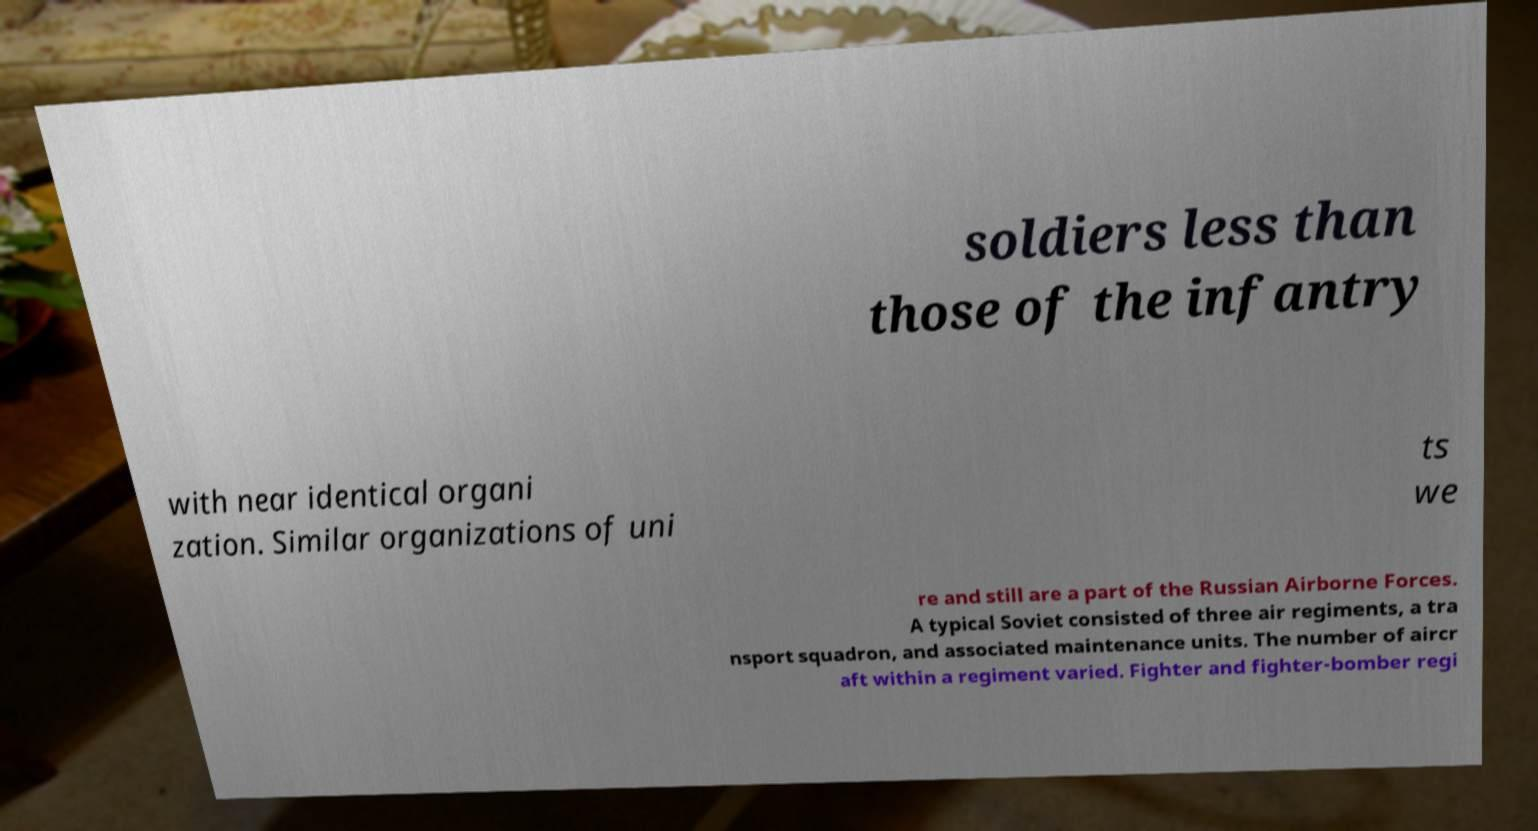Could you assist in decoding the text presented in this image and type it out clearly? soldiers less than those of the infantry with near identical organi zation. Similar organizations of uni ts we re and still are a part of the Russian Airborne Forces. A typical Soviet consisted of three air regiments, a tra nsport squadron, and associated maintenance units. The number of aircr aft within a regiment varied. Fighter and fighter-bomber regi 